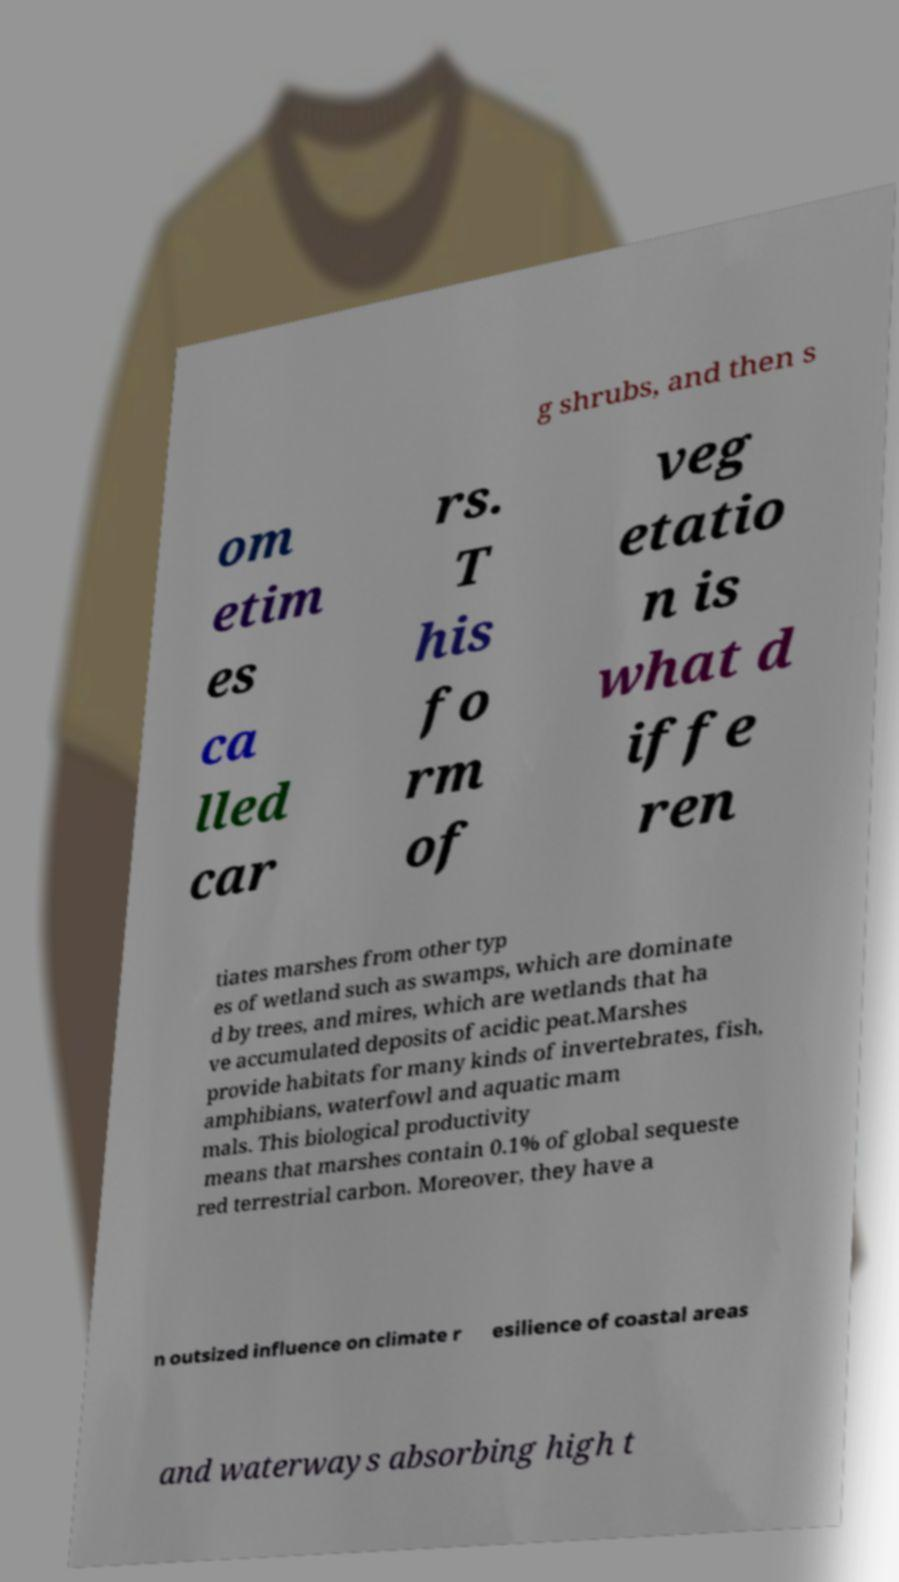I need the written content from this picture converted into text. Can you do that? g shrubs, and then s om etim es ca lled car rs. T his fo rm of veg etatio n is what d iffe ren tiates marshes from other typ es of wetland such as swamps, which are dominate d by trees, and mires, which are wetlands that ha ve accumulated deposits of acidic peat.Marshes provide habitats for many kinds of invertebrates, fish, amphibians, waterfowl and aquatic mam mals. This biological productivity means that marshes contain 0.1% of global sequeste red terrestrial carbon. Moreover, they have a n outsized influence on climate r esilience of coastal areas and waterways absorbing high t 